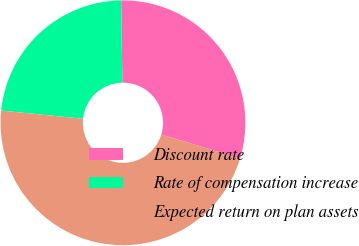Convert chart. <chart><loc_0><loc_0><loc_500><loc_500><pie_chart><fcel>Discount rate<fcel>Rate of compensation increase<fcel>Expected return on plan assets<nl><fcel>29.95%<fcel>23.17%<fcel>46.87%<nl></chart> 